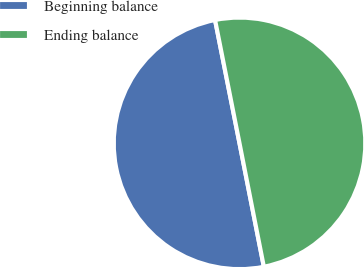Convert chart. <chart><loc_0><loc_0><loc_500><loc_500><pie_chart><fcel>Beginning balance<fcel>Ending balance<nl><fcel>49.98%<fcel>50.02%<nl></chart> 